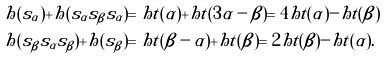Convert formula to latex. <formula><loc_0><loc_0><loc_500><loc_500>& h ( s _ { \alpha } ) + h ( s _ { \alpha } s _ { \beta } s _ { \alpha } ) = h t ( \alpha ) + h t ( 3 \alpha - \beta ) = 4 h t ( \alpha ) - h t ( \beta ) \\ & h ( s _ { \beta } s _ { \alpha } s _ { \beta } ) + h ( s _ { \beta } ) = h t ( \beta - \alpha ) + h t ( \beta ) = 2 h t ( \beta ) - h t ( \alpha ) .</formula> 